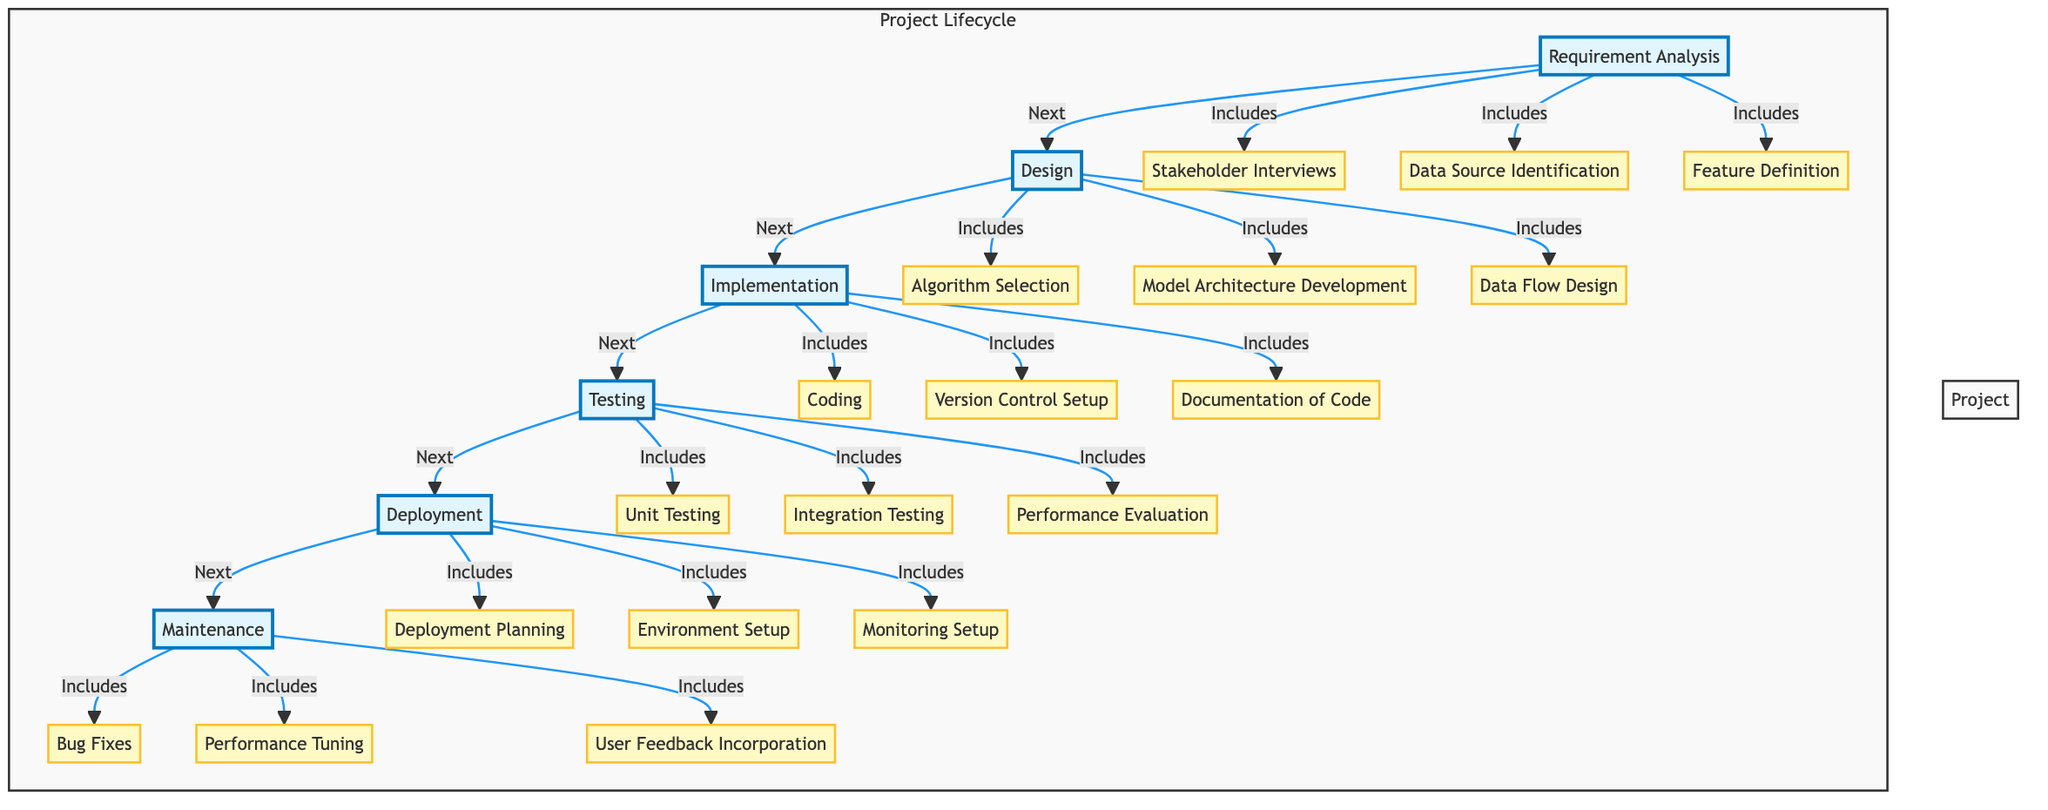What is the first stage of the project lifecycle? The diagram shows that "Requirement Analysis" is the first stage that initiates the project lifecycle.
Answer: Requirement Analysis How many key activities are listed under the Testing stage? The Testing stage includes three key activities: Unit Testing, Integration Testing, and Performance Evaluation. Thus, there are three key activities listed.
Answer: 3 What stage follows Deployment? According to the flow of the diagram, the stage that follows Deployment is Maintenance.
Answer: Maintenance Which activity is associated with Requirement Analysis? The diagram shows several key activities under Requirement Analysis, one of which is Stakeholder Interviews.
Answer: Stakeholder Interviews What is the last stage in the project lifecycle? Based on the sequential flow in the diagram, the last stage in the project lifecycle is Maintenance.
Answer: Maintenance What are the two activities included in the Design stage? Within the Design stage, there are three activities, two of which are Algorithm Selection and Model Architecture Development.
Answer: Algorithm Selection, Model Architecture Development How does Implementation connect to Testing in the flow? The Implementation stage flows directly into the Testing stage, as indicated by the arrow linking the two stages in the diagram.
Answer: Directly flows into What are the three key activities listed under Maintenance? The Maintenance stage includes Bug Fixes, Performance Tuning, and User Feedback Incorporation, which are specified in the diagram.
Answer: Bug Fixes, Performance Tuning, User Feedback Incorporation What is the total number of stages in the project lifecycle? Counting all stages listed in the diagram, there are six stages: Requirement Analysis, Design, Implementation, Testing, Deployment, and Maintenance.
Answer: 6 